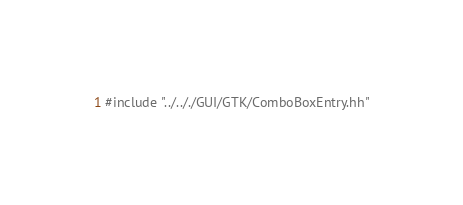Convert code to text. <code><loc_0><loc_0><loc_500><loc_500><_C++_>
#include "../.././GUI/GTK/ComboBoxEntry.hh"

</code> 